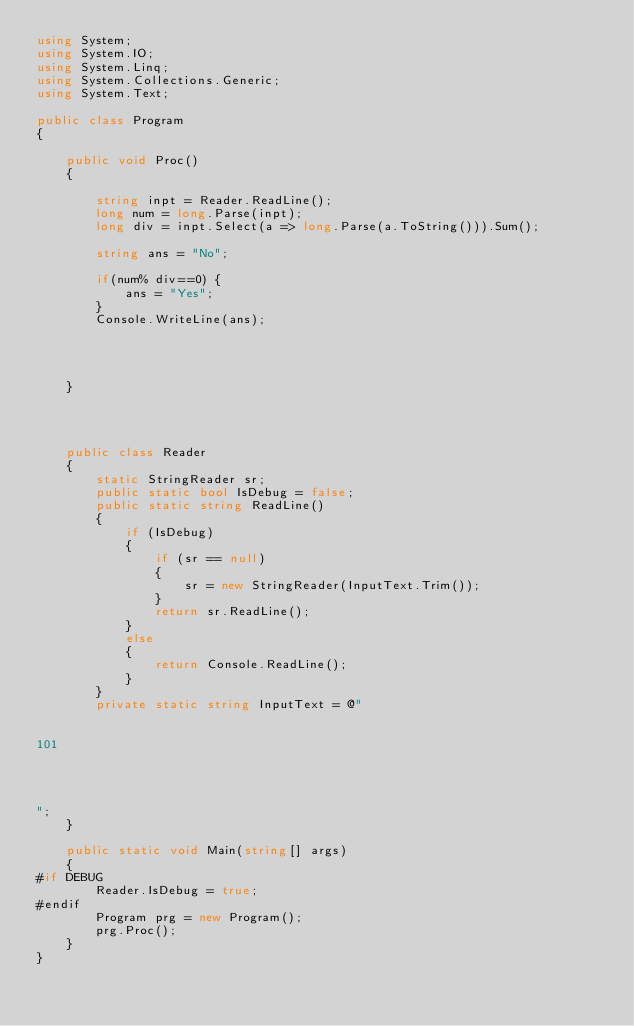Convert code to text. <code><loc_0><loc_0><loc_500><loc_500><_C#_>using System;
using System.IO;
using System.Linq;
using System.Collections.Generic;
using System.Text;

public class Program
{

    public void Proc()
    {

        string inpt = Reader.ReadLine();
        long num = long.Parse(inpt);
        long div = inpt.Select(a => long.Parse(a.ToString())).Sum();

        string ans = "No";

        if(num% div==0) {
            ans = "Yes";
        }
        Console.WriteLine(ans);




    }




    public class Reader
    {
        static StringReader sr;
        public static bool IsDebug = false;
        public static string ReadLine()
        {
            if (IsDebug)
            {
                if (sr == null)
                {
                    sr = new StringReader(InputText.Trim());
                }
                return sr.ReadLine();
            }
            else
            {
                return Console.ReadLine();
            }
        }
        private static string InputText = @"


101




";
    }

    public static void Main(string[] args)
    {
#if DEBUG
        Reader.IsDebug = true;
#endif
        Program prg = new Program();
        prg.Proc();
    }
}
</code> 